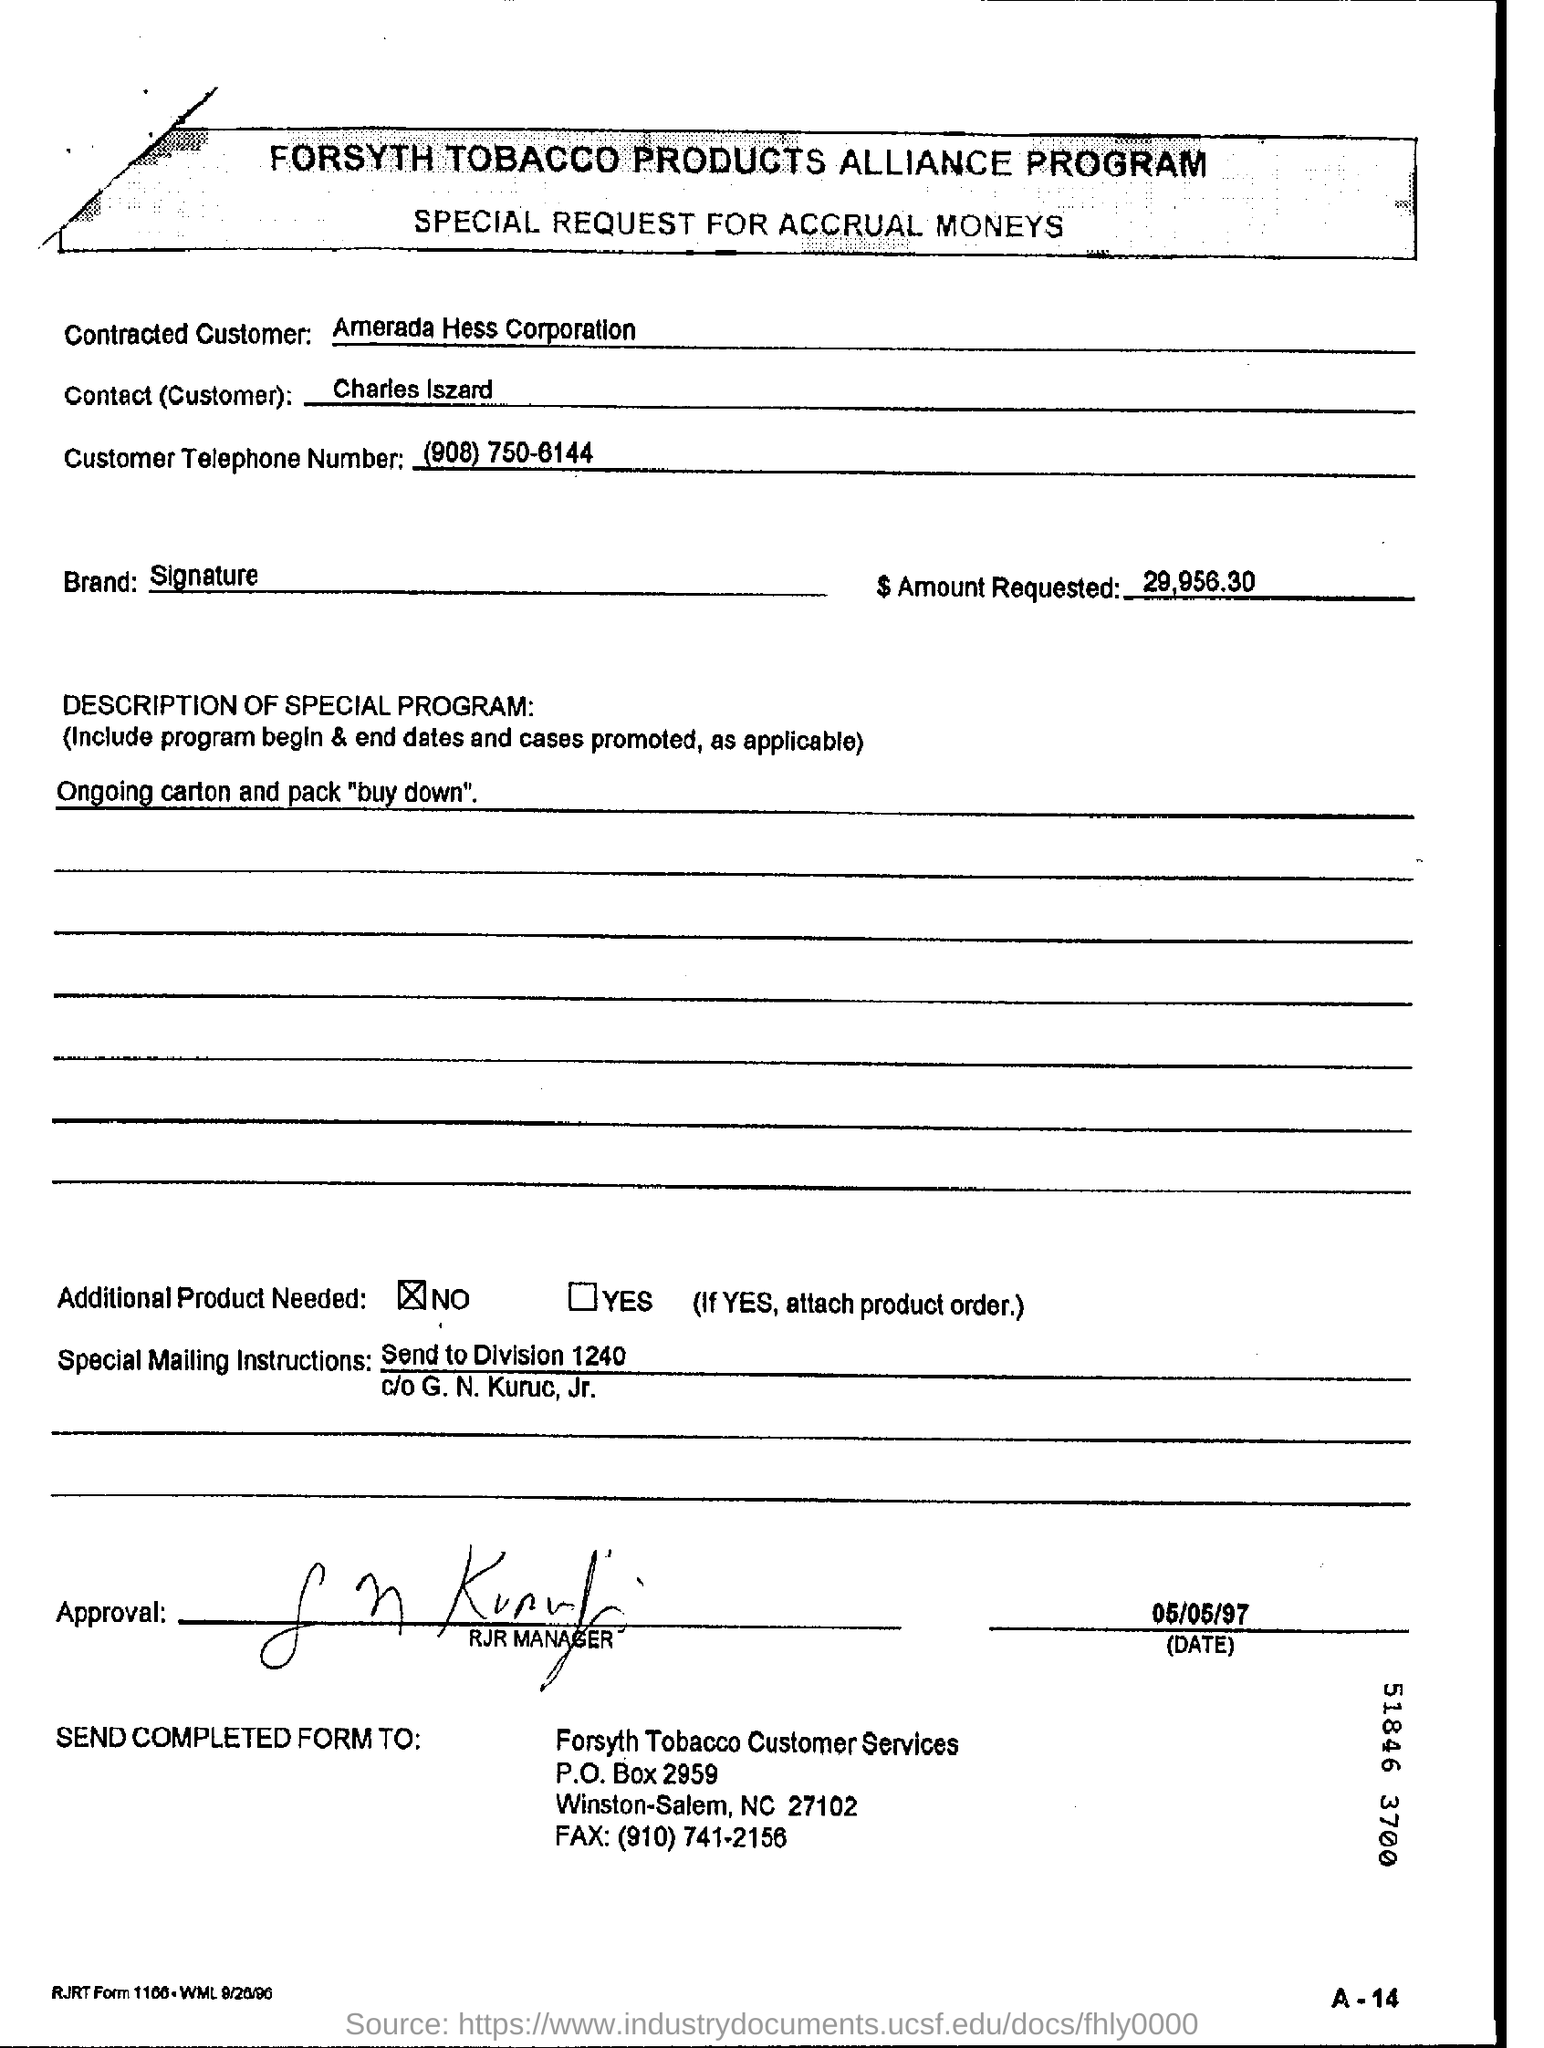Who is the Contracted Customer?
Ensure brevity in your answer.  Amerada Hess Corporation. Which is the Brand?
Provide a succinct answer. Signature. What is the Customer Telephone Number?
Give a very brief answer. (908) 750-6144. What is the date on the document?
Keep it short and to the point. 05/05/97. 